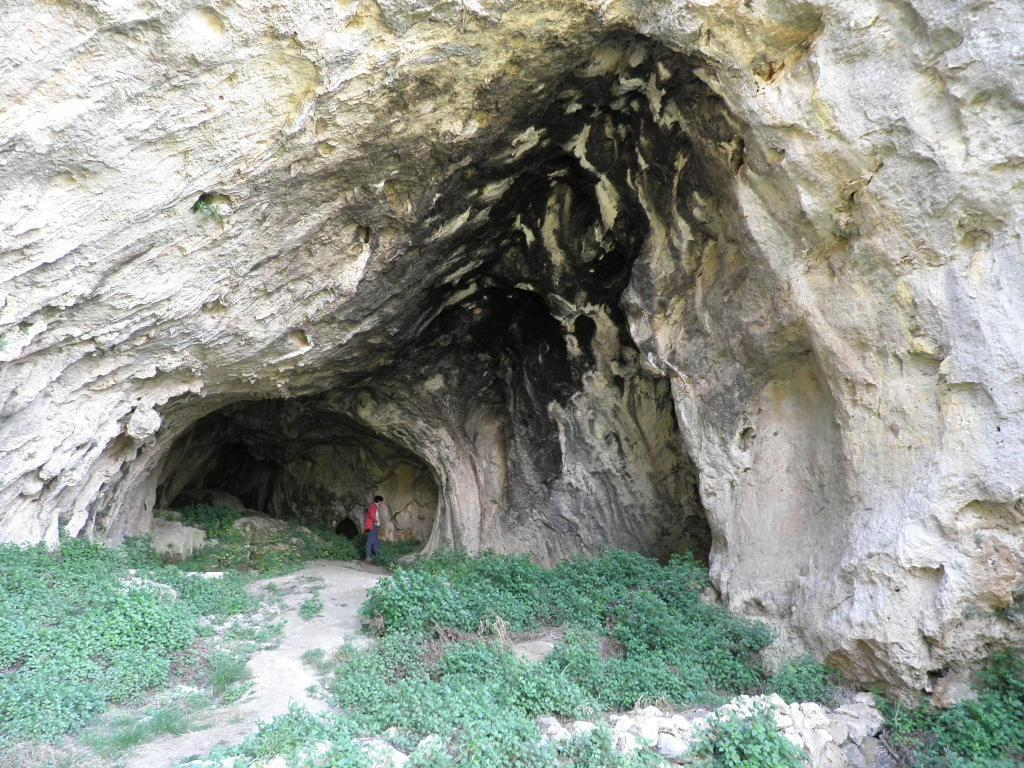Who or what is present in the image? There is a person in the image. What is the person wearing? The person is wearing a red dress. Where is the person located in the image? The person is standing inside a cave. Can you describe the cave in the image? The cave is huge. What can be seen outside the cave in the image? There are many plants in front of the cave on the land. What type of leather material is used to make the cave in the image? There is no leather material used to make the cave in the image; it is a natural formation made of rock or other geological materials. 